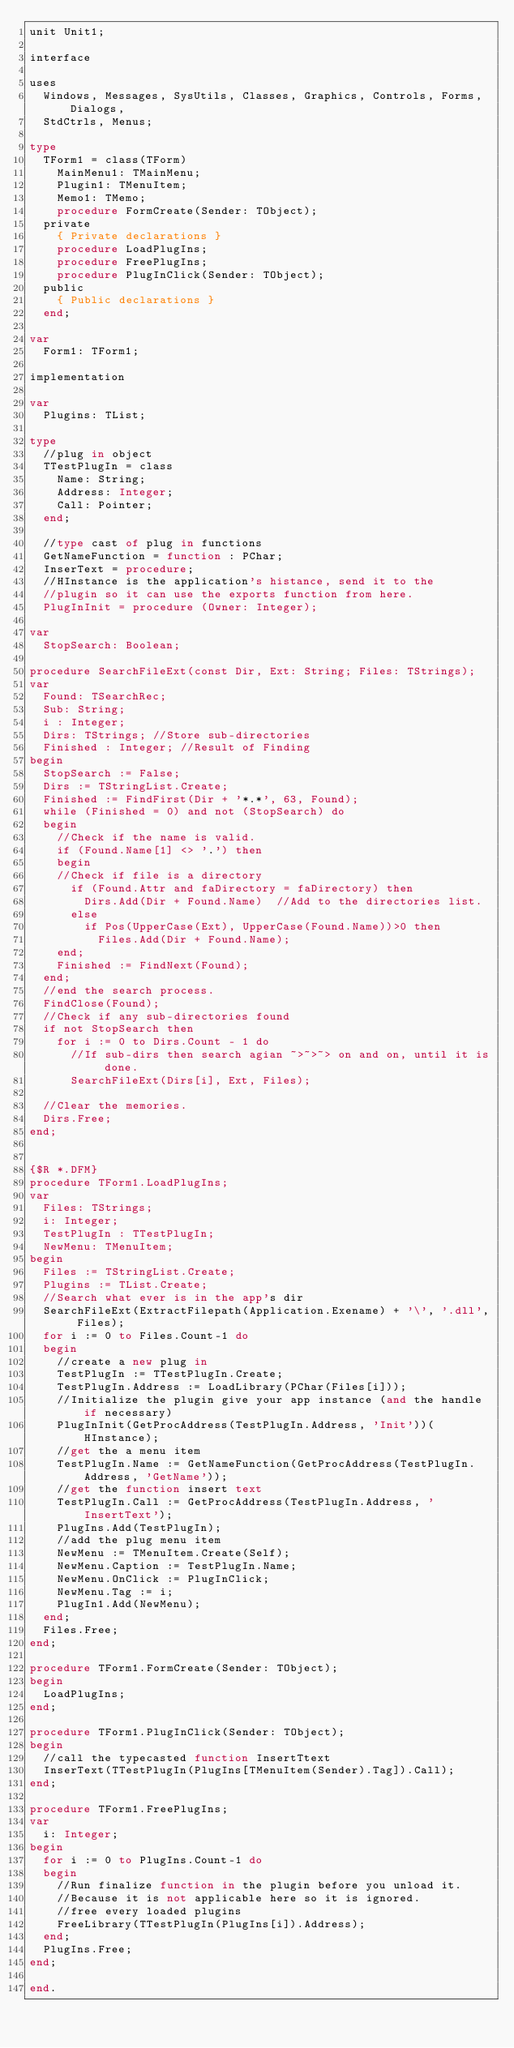Convert code to text. <code><loc_0><loc_0><loc_500><loc_500><_Pascal_>unit Unit1;

interface

uses
  Windows, Messages, SysUtils, Classes, Graphics, Controls, Forms, Dialogs,
  StdCtrls, Menus;

type
  TForm1 = class(TForm)
    MainMenu1: TMainMenu;
    Plugin1: TMenuItem;
    Memo1: TMemo;
    procedure FormCreate(Sender: TObject);
  private
    { Private declarations }
    procedure LoadPlugIns;
    procedure FreePlugIns;
    procedure PlugInClick(Sender: TObject);
  public
    { Public declarations }
  end;

var
  Form1: TForm1;

implementation

var
	Plugins: TList;

type
  //plug in object
	TTestPlugIn = class
  	Name: String;
    Address: Integer;
    Call: Pointer;
  end;

  //type cast of plug in functions
  GetNameFunction = function : PChar;
  InserText = procedure;
  //HInstance is the application's histance, send it to the
  //plugin so it can use the exports function from here.
	PlugInInit = procedure (Owner: Integer);

var
	StopSearch: Boolean;
  
procedure SearchFileExt(const Dir, Ext: String; Files: TStrings);
var
	Found: TSearchRec;
  Sub: String;
  i : Integer;
  Dirs: TStrings; //Store sub-directories
  Finished : Integer; //Result of Finding
begin
	StopSearch := False;
	Dirs := TStringList.Create;
	Finished := FindFirst(Dir + '*.*', 63, Found);
  while (Finished = 0) and not (StopSearch) do
  begin
  	//Check if the name is valid.
  	if (Found.Name[1] <> '.') then
 		begin
    //Check if file is a directory
    	if (Found.Attr and faDirectory = faDirectory) then
      	Dirs.Add(Dir + Found.Name)  //Add to the directories list.
    	else
   			if Pos(UpperCase(Ext), UpperCase(Found.Name))>0 then
      		Files.Add(Dir + Found.Name);
    end;
		Finished := FindNext(Found);
  end;
  //end the search process.
  FindClose(Found);
  //Check if any sub-directories found
	if not StopSearch then
  	for i := 0 to Dirs.Count - 1 do
    	//If sub-dirs then search agian ~>~>~> on and on, until it is done.
			SearchFileExt(Dirs[i], Ext, Files);

  //Clear the memories.
  Dirs.Free;
end;


{$R *.DFM}
procedure TForm1.LoadPlugIns;
var
	Files: TStrings;
  i: Integer;
  TestPlugIn : TTestPlugIn;
  NewMenu: TMenuItem;
begin
	Files := TStringList.Create;
  Plugins := TList.Create;
  //Search what ever is in the app's dir
	SearchFileExt(ExtractFilepath(Application.Exename) + '\', '.dll', Files);
	for i := 0 to Files.Count-1 do
  begin
  	//create a new plug in
    TestPlugIn := TTestPlugIn.Create;
		TestPlugIn.Address := LoadLibrary(PChar(Files[i]));
    //Initialize the plugin give your app instance (and the handle if necessary)
    PlugInInit(GetProcAddress(TestPlugIn.Address, 'Init'))(HInstance);
    //get the a menu item
    TestPlugIn.Name := GetNameFunction(GetProcAddress(TestPlugIn.Address, 'GetName'));
    //get the function insert text
    TestPlugIn.Call := GetProcAddress(TestPlugIn.Address, 'InsertText');
    PlugIns.Add(TestPlugIn);
		//add the plug menu item
    NewMenu := TMenuItem.Create(Self);
    NewMenu.Caption := TestPlugIn.Name;
    NewMenu.OnClick := PlugInClick;
    NewMenu.Tag := i;
    PlugIn1.Add(NewMenu);
  end;
  Files.Free;
end;

procedure TForm1.FormCreate(Sender: TObject);
begin
	LoadPlugIns;
end;

procedure TForm1.PlugInClick(Sender: TObject);
begin
	//call the typecasted function InsertTtext
	InserText(TTestPlugIn(PlugIns[TMenuItem(Sender).Tag]).Call);
end;

procedure TForm1.FreePlugIns;
var
	i: Integer;
begin
	for i := 0 to PlugIns.Count-1 do
  begin
    //Run finalize function in the plugin before you unload it.
    //Because it is not applicable here so it is ignored.
  	//free every loaded plugins
  	FreeLibrary(TTestPlugIn(PlugIns[i]).Address);
  end;
	PlugIns.Free;
end;

end.
</code> 